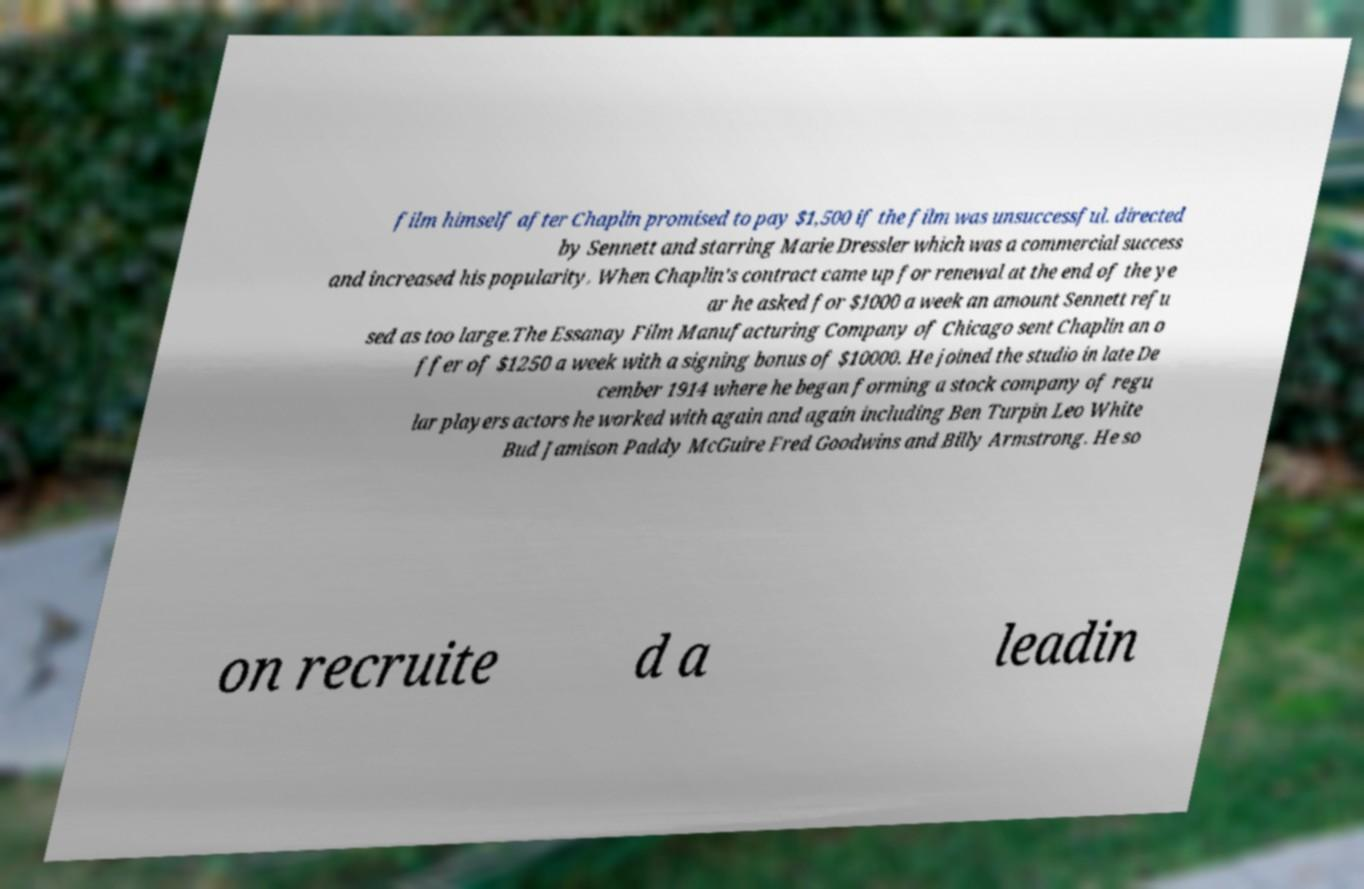Could you extract and type out the text from this image? film himself after Chaplin promised to pay $1,500 if the film was unsuccessful. directed by Sennett and starring Marie Dressler which was a commercial success and increased his popularity. When Chaplin's contract came up for renewal at the end of the ye ar he asked for $1000 a week an amount Sennett refu sed as too large.The Essanay Film Manufacturing Company of Chicago sent Chaplin an o ffer of $1250 a week with a signing bonus of $10000. He joined the studio in late De cember 1914 where he began forming a stock company of regu lar players actors he worked with again and again including Ben Turpin Leo White Bud Jamison Paddy McGuire Fred Goodwins and Billy Armstrong. He so on recruite d a leadin 